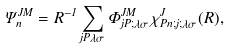<formula> <loc_0><loc_0><loc_500><loc_500>\Psi ^ { J M } _ { n } = R ^ { - 1 } \sum _ { j P \lambda \sigma } \Phi ^ { J M } _ { j P ; \lambda \sigma } \, \chi ^ { J } _ { P n ; j ; \lambda \sigma } ( R ) ,</formula> 